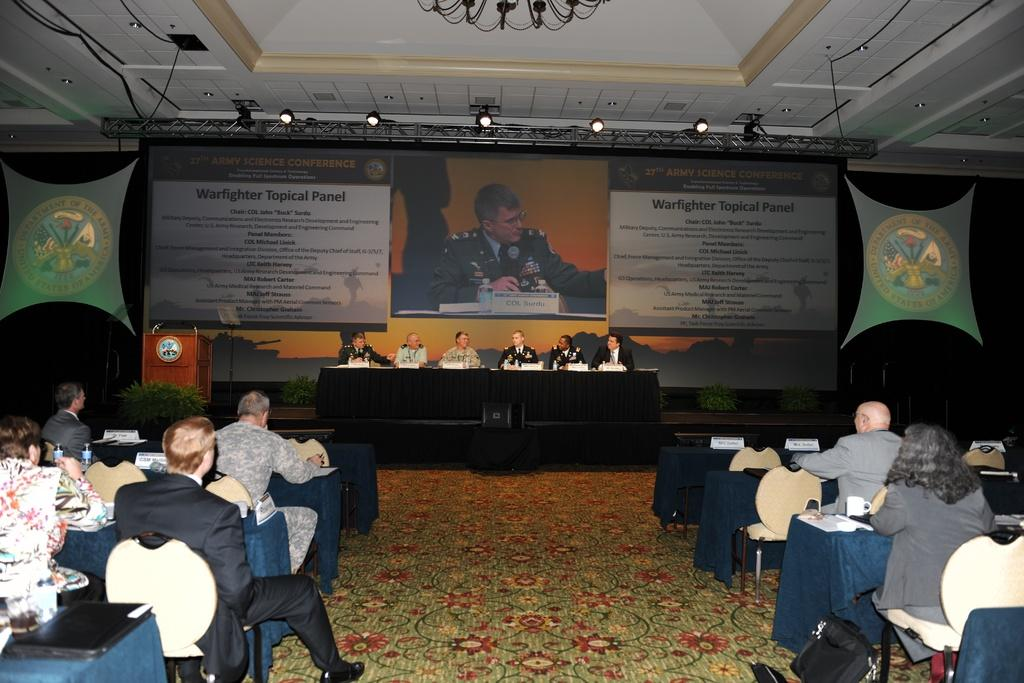How many people are in the image? There is a group of people in the image. What are the people doing in the image? The people are sitting in chairs. Where are the chairs located in relation to the table? The chairs are in front of a table. What can be seen on the big screen projection in the image? Unfortunately, the content of the big screen projection cannot be determined from the image. How many steps does the boy take to reach the table in the image? There is no boy present in the image, and therefore no steps can be counted. 